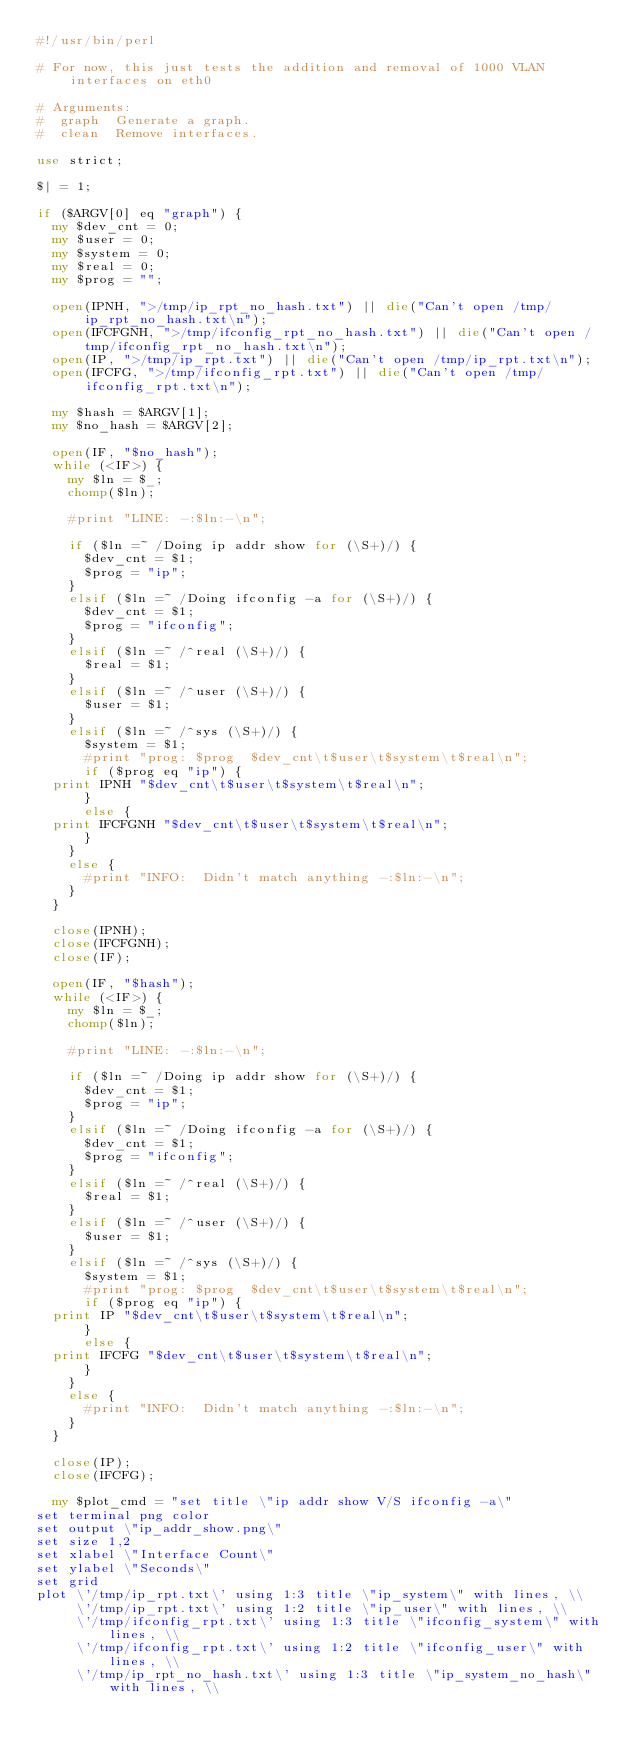<code> <loc_0><loc_0><loc_500><loc_500><_Perl_>#!/usr/bin/perl

# For now, this just tests the addition and removal of 1000 VLAN interfaces on eth0

# Arguments:
#  graph  Generate a graph.
#  clean  Remove interfaces.

use strict;

$| = 1;

if ($ARGV[0] eq "graph") {
  my $dev_cnt = 0;
  my $user = 0;
  my $system = 0;
  my $real = 0;
  my $prog = "";

  open(IPNH, ">/tmp/ip_rpt_no_hash.txt") || die("Can't open /tmp/ip_rpt_no_hash.txt\n");
  open(IFCFGNH, ">/tmp/ifconfig_rpt_no_hash.txt") || die("Can't open /tmp/ifconfig_rpt_no_hash.txt\n");
  open(IP, ">/tmp/ip_rpt.txt") || die("Can't open /tmp/ip_rpt.txt\n");
  open(IFCFG, ">/tmp/ifconfig_rpt.txt") || die("Can't open /tmp/ifconfig_rpt.txt\n");

  my $hash = $ARGV[1];
  my $no_hash = $ARGV[2];

  open(IF, "$no_hash");
  while (<IF>) {
    my $ln = $_;
    chomp($ln);

    #print "LINE: -:$ln:-\n";

    if ($ln =~ /Doing ip addr show for (\S+)/) {
      $dev_cnt = $1;
      $prog = "ip";
    }
    elsif ($ln =~ /Doing ifconfig -a for (\S+)/) {
      $dev_cnt = $1;
      $prog = "ifconfig";
    }
    elsif ($ln =~ /^real (\S+)/) {
      $real = $1;
    }
    elsif ($ln =~ /^user (\S+)/) {
      $user = $1;
    }
    elsif ($ln =~ /^sys (\S+)/) {
      $system = $1;
      #print "prog: $prog  $dev_cnt\t$user\t$system\t$real\n";
      if ($prog eq "ip") {
	print IPNH "$dev_cnt\t$user\t$system\t$real\n";
      }
      else {
	print IFCFGNH "$dev_cnt\t$user\t$system\t$real\n";
      }
    }
    else {
      #print "INFO:  Didn't match anything -:$ln:-\n";
    }
  }

  close(IPNH);
  close(IFCFGNH);
  close(IF);

  open(IF, "$hash");
  while (<IF>) {
    my $ln = $_;
    chomp($ln);

    #print "LINE: -:$ln:-\n";

    if ($ln =~ /Doing ip addr show for (\S+)/) {
      $dev_cnt = $1;
      $prog = "ip";
    }
    elsif ($ln =~ /Doing ifconfig -a for (\S+)/) {
      $dev_cnt = $1;
      $prog = "ifconfig";
    }
    elsif ($ln =~ /^real (\S+)/) {
      $real = $1;
    }
    elsif ($ln =~ /^user (\S+)/) {
      $user = $1;
    }
    elsif ($ln =~ /^sys (\S+)/) {
      $system = $1;
      #print "prog: $prog  $dev_cnt\t$user\t$system\t$real\n";
      if ($prog eq "ip") {
	print IP "$dev_cnt\t$user\t$system\t$real\n";
      }
      else {
	print IFCFG "$dev_cnt\t$user\t$system\t$real\n";
      }
    }
    else {
      #print "INFO:  Didn't match anything -:$ln:-\n";
    }
  }

  close(IP);
  close(IFCFG);

  my $plot_cmd = "set title \"ip addr show V/S ifconfig -a\"
set terminal png color
set output \"ip_addr_show.png\"
set size 1,2
set xlabel \"Interface Count\"
set ylabel \"Seconds\"
set grid
plot \'/tmp/ip_rpt.txt\' using 1:3 title \"ip_system\" with lines, \\
     \'/tmp/ip_rpt.txt\' using 1:2 title \"ip_user\" with lines, \\
     \'/tmp/ifconfig_rpt.txt\' using 1:3 title \"ifconfig_system\" with lines, \\
     \'/tmp/ifconfig_rpt.txt\' using 1:2 title \"ifconfig_user\" with lines, \\
     \'/tmp/ip_rpt_no_hash.txt\' using 1:3 title \"ip_system_no_hash\" with lines, \\</code> 